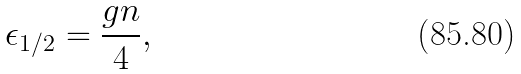Convert formula to latex. <formula><loc_0><loc_0><loc_500><loc_500>\epsilon _ { 1 / 2 } = \frac { g n } { 4 } ,</formula> 